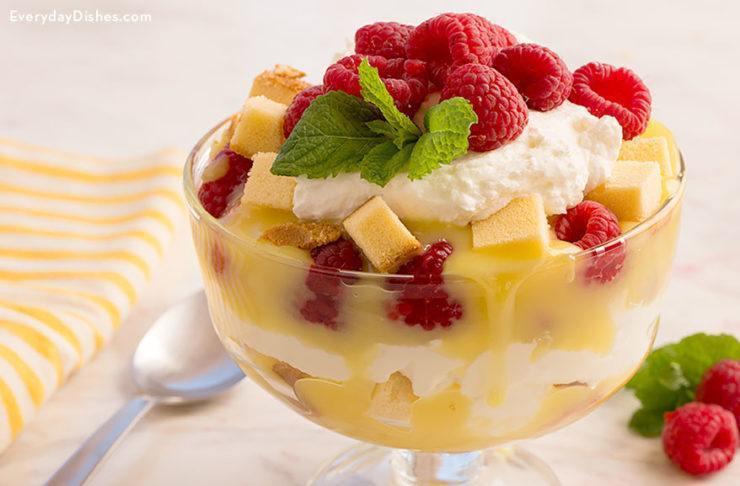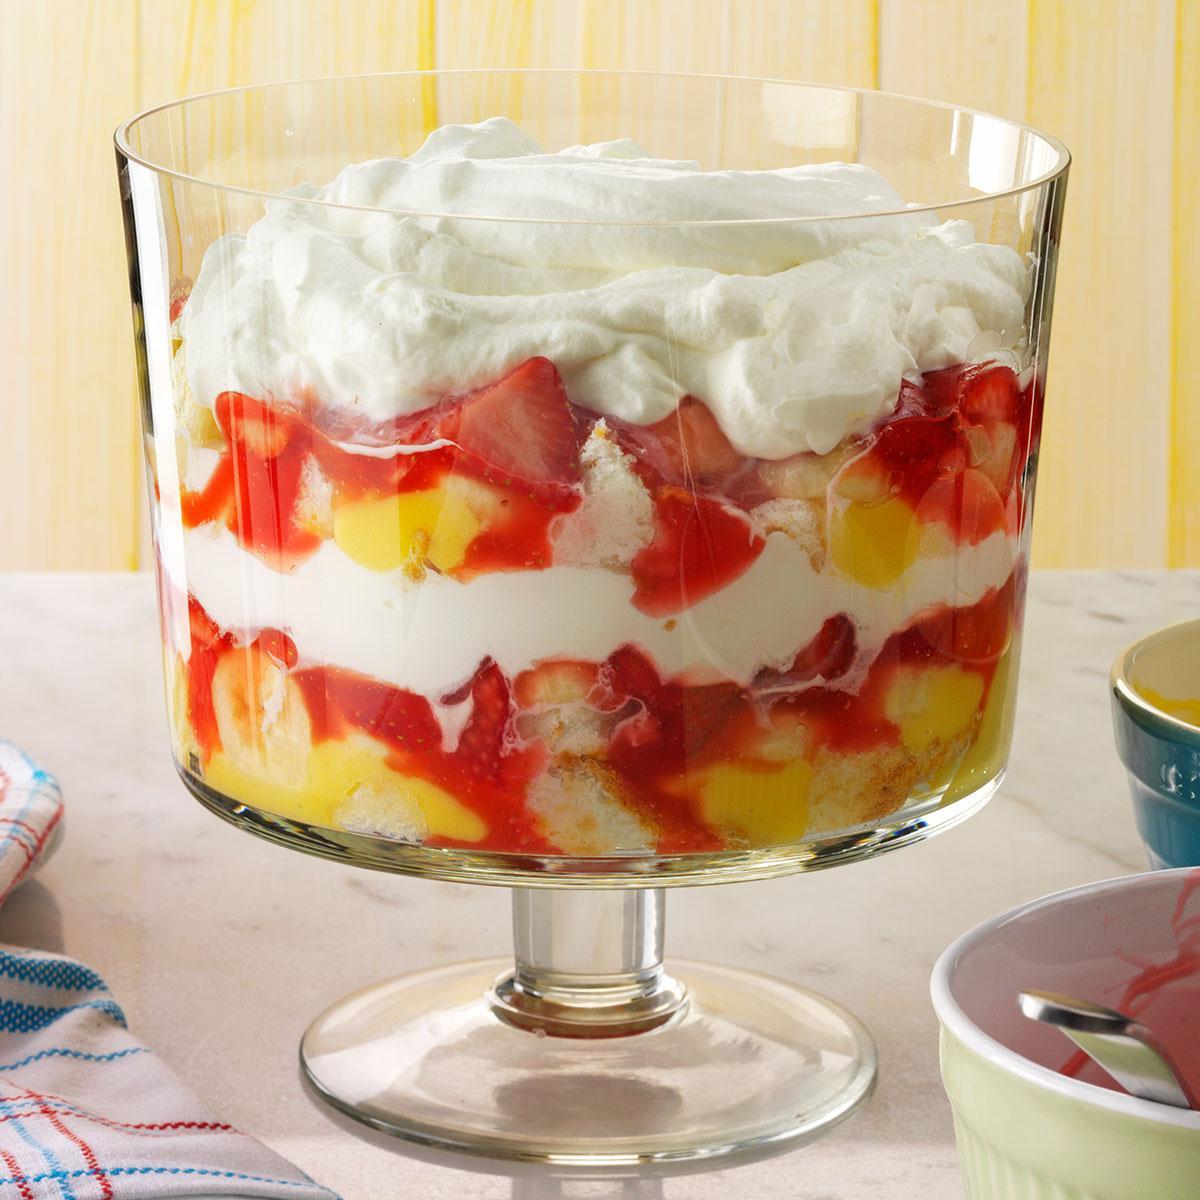The first image is the image on the left, the second image is the image on the right. Given the left and right images, does the statement "One image shows a layered dessert garnished with blueberries, and all desserts shown in left and right images are garnished with some type of berry." hold true? Answer yes or no. No. The first image is the image on the left, the second image is the image on the right. Considering the images on both sides, is "One of the images contains a lemon in the background on the table." valid? Answer yes or no. No. 